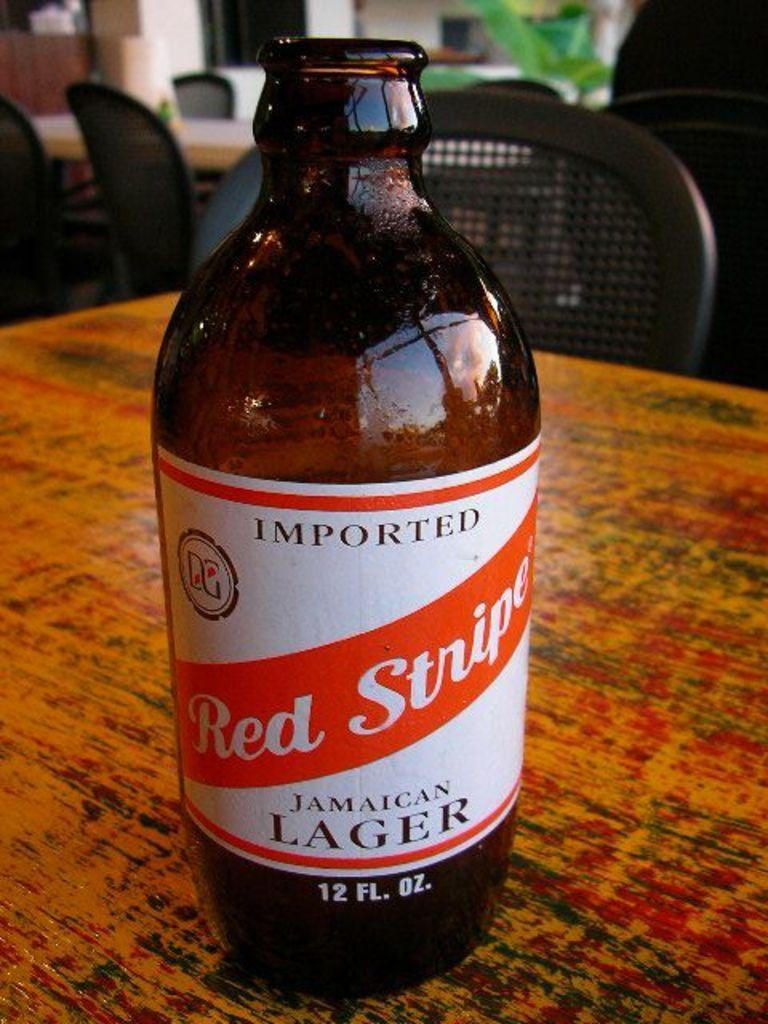How would you summarize this image in a sentence or two? There is a bottle on the table. In the background there are chairs,table,plant and a wall. 